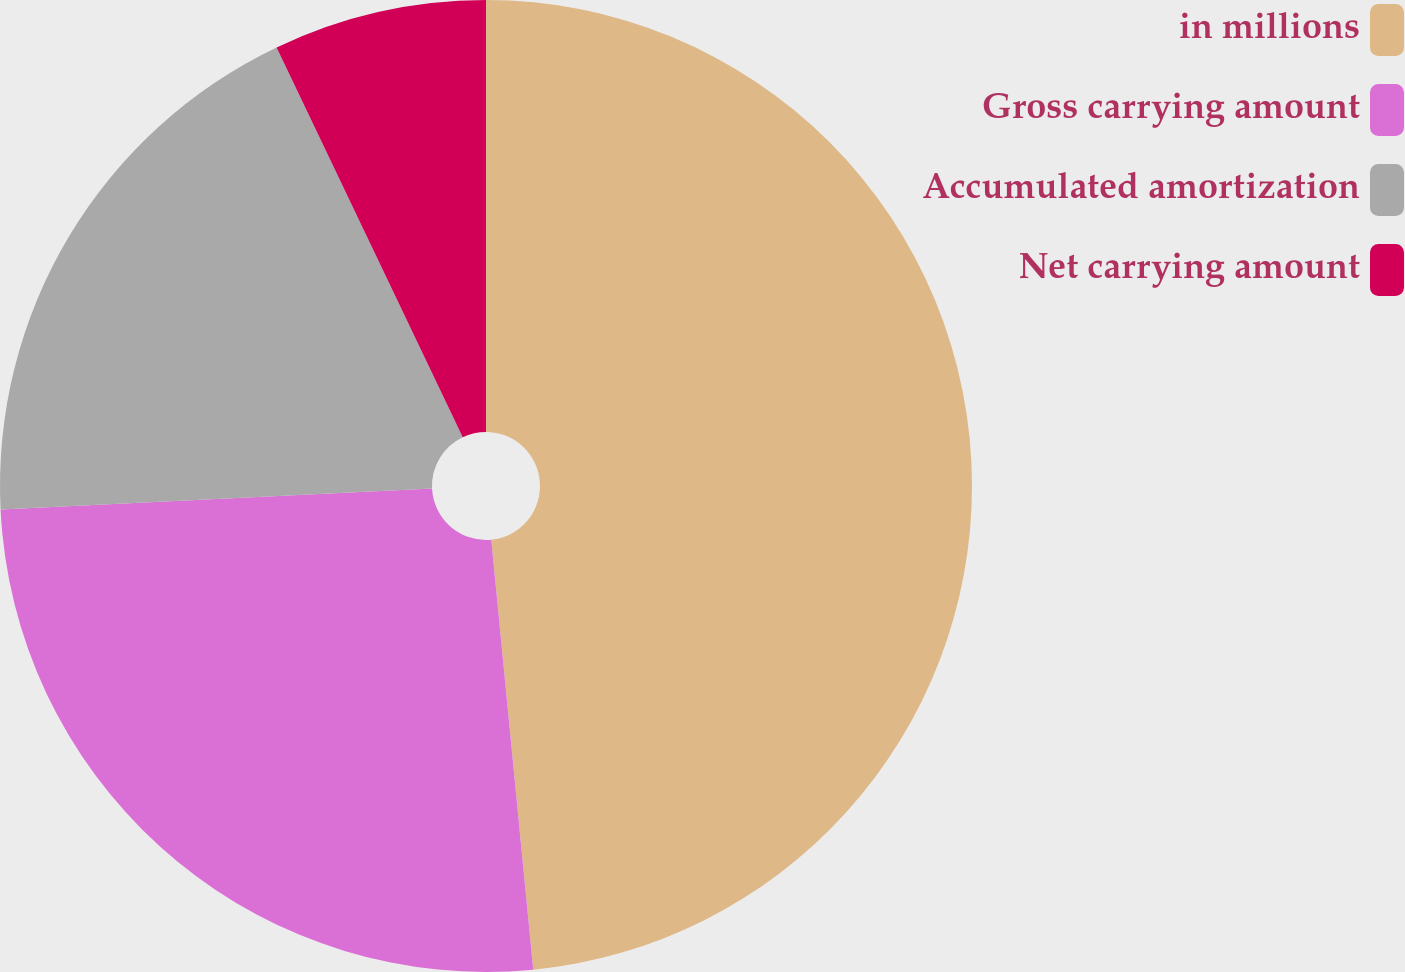<chart> <loc_0><loc_0><loc_500><loc_500><pie_chart><fcel>in millions<fcel>Gross carrying amount<fcel>Accumulated amortization<fcel>Net carrying amount<nl><fcel>48.45%<fcel>25.78%<fcel>18.68%<fcel>7.09%<nl></chart> 